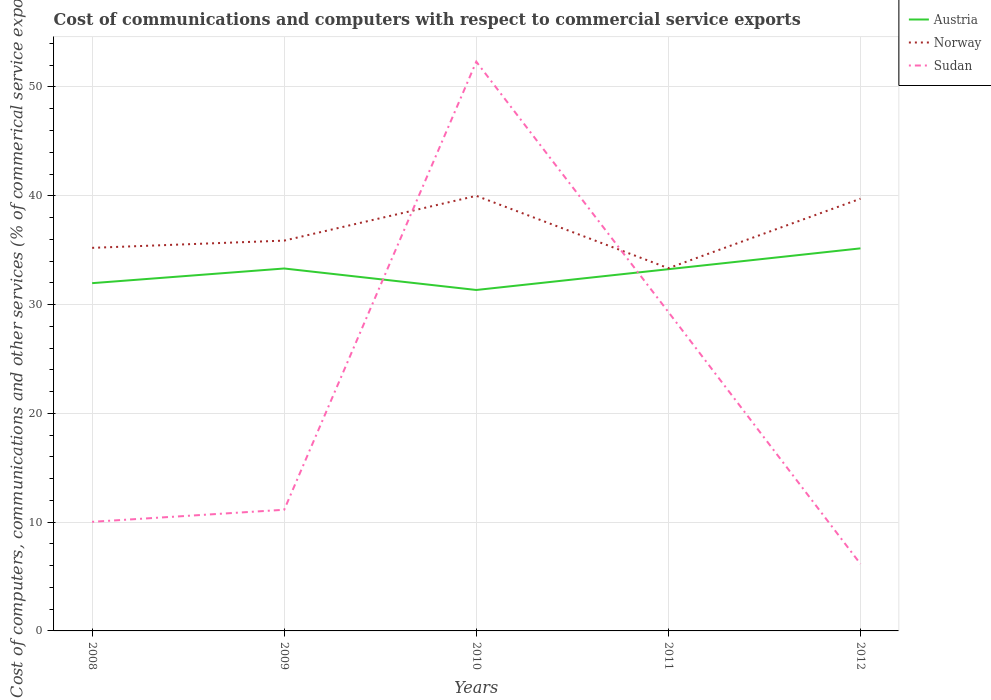Does the line corresponding to Norway intersect with the line corresponding to Sudan?
Offer a terse response. Yes. Is the number of lines equal to the number of legend labels?
Provide a short and direct response. Yes. Across all years, what is the maximum cost of communications and computers in Norway?
Provide a succinct answer. 33.34. What is the total cost of communications and computers in Sudan in the graph?
Keep it short and to the point. -19.29. What is the difference between the highest and the second highest cost of communications and computers in Austria?
Keep it short and to the point. 3.83. What is the difference between the highest and the lowest cost of communications and computers in Norway?
Provide a short and direct response. 2. Does the graph contain grids?
Your answer should be very brief. Yes. How many legend labels are there?
Your answer should be compact. 3. How are the legend labels stacked?
Give a very brief answer. Vertical. What is the title of the graph?
Offer a terse response. Cost of communications and computers with respect to commercial service exports. What is the label or title of the Y-axis?
Your response must be concise. Cost of computers, communications and other services (% of commerical service exports). What is the Cost of computers, communications and other services (% of commerical service exports) in Austria in 2008?
Provide a succinct answer. 31.97. What is the Cost of computers, communications and other services (% of commerical service exports) in Norway in 2008?
Ensure brevity in your answer.  35.21. What is the Cost of computers, communications and other services (% of commerical service exports) of Sudan in 2008?
Provide a short and direct response. 10.03. What is the Cost of computers, communications and other services (% of commerical service exports) in Austria in 2009?
Offer a terse response. 33.31. What is the Cost of computers, communications and other services (% of commerical service exports) of Norway in 2009?
Provide a short and direct response. 35.88. What is the Cost of computers, communications and other services (% of commerical service exports) in Sudan in 2009?
Your answer should be compact. 11.14. What is the Cost of computers, communications and other services (% of commerical service exports) in Austria in 2010?
Provide a short and direct response. 31.34. What is the Cost of computers, communications and other services (% of commerical service exports) in Norway in 2010?
Keep it short and to the point. 39.99. What is the Cost of computers, communications and other services (% of commerical service exports) of Sudan in 2010?
Keep it short and to the point. 52.32. What is the Cost of computers, communications and other services (% of commerical service exports) in Austria in 2011?
Your answer should be very brief. 33.25. What is the Cost of computers, communications and other services (% of commerical service exports) of Norway in 2011?
Your response must be concise. 33.34. What is the Cost of computers, communications and other services (% of commerical service exports) in Sudan in 2011?
Your response must be concise. 29.31. What is the Cost of computers, communications and other services (% of commerical service exports) of Austria in 2012?
Keep it short and to the point. 35.16. What is the Cost of computers, communications and other services (% of commerical service exports) of Norway in 2012?
Offer a very short reply. 39.73. What is the Cost of computers, communications and other services (% of commerical service exports) of Sudan in 2012?
Offer a very short reply. 6.16. Across all years, what is the maximum Cost of computers, communications and other services (% of commerical service exports) of Austria?
Your answer should be very brief. 35.16. Across all years, what is the maximum Cost of computers, communications and other services (% of commerical service exports) in Norway?
Offer a terse response. 39.99. Across all years, what is the maximum Cost of computers, communications and other services (% of commerical service exports) in Sudan?
Provide a short and direct response. 52.32. Across all years, what is the minimum Cost of computers, communications and other services (% of commerical service exports) of Austria?
Your response must be concise. 31.34. Across all years, what is the minimum Cost of computers, communications and other services (% of commerical service exports) in Norway?
Make the answer very short. 33.34. Across all years, what is the minimum Cost of computers, communications and other services (% of commerical service exports) in Sudan?
Provide a short and direct response. 6.16. What is the total Cost of computers, communications and other services (% of commerical service exports) of Austria in the graph?
Offer a terse response. 165.03. What is the total Cost of computers, communications and other services (% of commerical service exports) in Norway in the graph?
Your response must be concise. 184.15. What is the total Cost of computers, communications and other services (% of commerical service exports) in Sudan in the graph?
Keep it short and to the point. 108.96. What is the difference between the Cost of computers, communications and other services (% of commerical service exports) of Austria in 2008 and that in 2009?
Offer a terse response. -1.35. What is the difference between the Cost of computers, communications and other services (% of commerical service exports) in Norway in 2008 and that in 2009?
Provide a succinct answer. -0.67. What is the difference between the Cost of computers, communications and other services (% of commerical service exports) in Sudan in 2008 and that in 2009?
Offer a terse response. -1.11. What is the difference between the Cost of computers, communications and other services (% of commerical service exports) in Austria in 2008 and that in 2010?
Your answer should be compact. 0.63. What is the difference between the Cost of computers, communications and other services (% of commerical service exports) of Norway in 2008 and that in 2010?
Provide a short and direct response. -4.78. What is the difference between the Cost of computers, communications and other services (% of commerical service exports) of Sudan in 2008 and that in 2010?
Provide a short and direct response. -42.3. What is the difference between the Cost of computers, communications and other services (% of commerical service exports) of Austria in 2008 and that in 2011?
Your answer should be compact. -1.28. What is the difference between the Cost of computers, communications and other services (% of commerical service exports) of Norway in 2008 and that in 2011?
Your response must be concise. 1.87. What is the difference between the Cost of computers, communications and other services (% of commerical service exports) in Sudan in 2008 and that in 2011?
Give a very brief answer. -19.29. What is the difference between the Cost of computers, communications and other services (% of commerical service exports) of Austria in 2008 and that in 2012?
Your answer should be compact. -3.2. What is the difference between the Cost of computers, communications and other services (% of commerical service exports) in Norway in 2008 and that in 2012?
Your answer should be very brief. -4.52. What is the difference between the Cost of computers, communications and other services (% of commerical service exports) in Sudan in 2008 and that in 2012?
Your response must be concise. 3.87. What is the difference between the Cost of computers, communications and other services (% of commerical service exports) in Austria in 2009 and that in 2010?
Give a very brief answer. 1.98. What is the difference between the Cost of computers, communications and other services (% of commerical service exports) in Norway in 2009 and that in 2010?
Give a very brief answer. -4.12. What is the difference between the Cost of computers, communications and other services (% of commerical service exports) in Sudan in 2009 and that in 2010?
Your response must be concise. -41.19. What is the difference between the Cost of computers, communications and other services (% of commerical service exports) in Austria in 2009 and that in 2011?
Ensure brevity in your answer.  0.06. What is the difference between the Cost of computers, communications and other services (% of commerical service exports) of Norway in 2009 and that in 2011?
Make the answer very short. 2.54. What is the difference between the Cost of computers, communications and other services (% of commerical service exports) in Sudan in 2009 and that in 2011?
Provide a succinct answer. -18.18. What is the difference between the Cost of computers, communications and other services (% of commerical service exports) of Austria in 2009 and that in 2012?
Keep it short and to the point. -1.85. What is the difference between the Cost of computers, communications and other services (% of commerical service exports) in Norway in 2009 and that in 2012?
Ensure brevity in your answer.  -3.85. What is the difference between the Cost of computers, communications and other services (% of commerical service exports) of Sudan in 2009 and that in 2012?
Your response must be concise. 4.98. What is the difference between the Cost of computers, communications and other services (% of commerical service exports) in Austria in 2010 and that in 2011?
Keep it short and to the point. -1.91. What is the difference between the Cost of computers, communications and other services (% of commerical service exports) of Norway in 2010 and that in 2011?
Your response must be concise. 6.65. What is the difference between the Cost of computers, communications and other services (% of commerical service exports) of Sudan in 2010 and that in 2011?
Give a very brief answer. 23.01. What is the difference between the Cost of computers, communications and other services (% of commerical service exports) of Austria in 2010 and that in 2012?
Give a very brief answer. -3.83. What is the difference between the Cost of computers, communications and other services (% of commerical service exports) in Norway in 2010 and that in 2012?
Your answer should be very brief. 0.27. What is the difference between the Cost of computers, communications and other services (% of commerical service exports) of Sudan in 2010 and that in 2012?
Ensure brevity in your answer.  46.16. What is the difference between the Cost of computers, communications and other services (% of commerical service exports) in Austria in 2011 and that in 2012?
Keep it short and to the point. -1.91. What is the difference between the Cost of computers, communications and other services (% of commerical service exports) of Norway in 2011 and that in 2012?
Offer a terse response. -6.39. What is the difference between the Cost of computers, communications and other services (% of commerical service exports) in Sudan in 2011 and that in 2012?
Provide a short and direct response. 23.15. What is the difference between the Cost of computers, communications and other services (% of commerical service exports) in Austria in 2008 and the Cost of computers, communications and other services (% of commerical service exports) in Norway in 2009?
Provide a short and direct response. -3.91. What is the difference between the Cost of computers, communications and other services (% of commerical service exports) of Austria in 2008 and the Cost of computers, communications and other services (% of commerical service exports) of Sudan in 2009?
Give a very brief answer. 20.83. What is the difference between the Cost of computers, communications and other services (% of commerical service exports) of Norway in 2008 and the Cost of computers, communications and other services (% of commerical service exports) of Sudan in 2009?
Provide a succinct answer. 24.07. What is the difference between the Cost of computers, communications and other services (% of commerical service exports) in Austria in 2008 and the Cost of computers, communications and other services (% of commerical service exports) in Norway in 2010?
Keep it short and to the point. -8.03. What is the difference between the Cost of computers, communications and other services (% of commerical service exports) of Austria in 2008 and the Cost of computers, communications and other services (% of commerical service exports) of Sudan in 2010?
Your answer should be very brief. -20.36. What is the difference between the Cost of computers, communications and other services (% of commerical service exports) of Norway in 2008 and the Cost of computers, communications and other services (% of commerical service exports) of Sudan in 2010?
Offer a very short reply. -17.11. What is the difference between the Cost of computers, communications and other services (% of commerical service exports) in Austria in 2008 and the Cost of computers, communications and other services (% of commerical service exports) in Norway in 2011?
Your answer should be very brief. -1.38. What is the difference between the Cost of computers, communications and other services (% of commerical service exports) in Austria in 2008 and the Cost of computers, communications and other services (% of commerical service exports) in Sudan in 2011?
Your response must be concise. 2.65. What is the difference between the Cost of computers, communications and other services (% of commerical service exports) of Norway in 2008 and the Cost of computers, communications and other services (% of commerical service exports) of Sudan in 2011?
Your answer should be compact. 5.9. What is the difference between the Cost of computers, communications and other services (% of commerical service exports) in Austria in 2008 and the Cost of computers, communications and other services (% of commerical service exports) in Norway in 2012?
Provide a succinct answer. -7.76. What is the difference between the Cost of computers, communications and other services (% of commerical service exports) in Austria in 2008 and the Cost of computers, communications and other services (% of commerical service exports) in Sudan in 2012?
Your answer should be compact. 25.81. What is the difference between the Cost of computers, communications and other services (% of commerical service exports) in Norway in 2008 and the Cost of computers, communications and other services (% of commerical service exports) in Sudan in 2012?
Your answer should be very brief. 29.05. What is the difference between the Cost of computers, communications and other services (% of commerical service exports) of Austria in 2009 and the Cost of computers, communications and other services (% of commerical service exports) of Norway in 2010?
Provide a succinct answer. -6.68. What is the difference between the Cost of computers, communications and other services (% of commerical service exports) in Austria in 2009 and the Cost of computers, communications and other services (% of commerical service exports) in Sudan in 2010?
Provide a short and direct response. -19.01. What is the difference between the Cost of computers, communications and other services (% of commerical service exports) in Norway in 2009 and the Cost of computers, communications and other services (% of commerical service exports) in Sudan in 2010?
Make the answer very short. -16.45. What is the difference between the Cost of computers, communications and other services (% of commerical service exports) in Austria in 2009 and the Cost of computers, communications and other services (% of commerical service exports) in Norway in 2011?
Provide a succinct answer. -0.03. What is the difference between the Cost of computers, communications and other services (% of commerical service exports) of Austria in 2009 and the Cost of computers, communications and other services (% of commerical service exports) of Sudan in 2011?
Your answer should be compact. 4. What is the difference between the Cost of computers, communications and other services (% of commerical service exports) in Norway in 2009 and the Cost of computers, communications and other services (% of commerical service exports) in Sudan in 2011?
Keep it short and to the point. 6.56. What is the difference between the Cost of computers, communications and other services (% of commerical service exports) in Austria in 2009 and the Cost of computers, communications and other services (% of commerical service exports) in Norway in 2012?
Provide a succinct answer. -6.41. What is the difference between the Cost of computers, communications and other services (% of commerical service exports) of Austria in 2009 and the Cost of computers, communications and other services (% of commerical service exports) of Sudan in 2012?
Provide a short and direct response. 27.16. What is the difference between the Cost of computers, communications and other services (% of commerical service exports) of Norway in 2009 and the Cost of computers, communications and other services (% of commerical service exports) of Sudan in 2012?
Your response must be concise. 29.72. What is the difference between the Cost of computers, communications and other services (% of commerical service exports) in Austria in 2010 and the Cost of computers, communications and other services (% of commerical service exports) in Norway in 2011?
Ensure brevity in your answer.  -2. What is the difference between the Cost of computers, communications and other services (% of commerical service exports) in Austria in 2010 and the Cost of computers, communications and other services (% of commerical service exports) in Sudan in 2011?
Provide a short and direct response. 2.03. What is the difference between the Cost of computers, communications and other services (% of commerical service exports) in Norway in 2010 and the Cost of computers, communications and other services (% of commerical service exports) in Sudan in 2011?
Provide a short and direct response. 10.68. What is the difference between the Cost of computers, communications and other services (% of commerical service exports) in Austria in 2010 and the Cost of computers, communications and other services (% of commerical service exports) in Norway in 2012?
Offer a terse response. -8.39. What is the difference between the Cost of computers, communications and other services (% of commerical service exports) of Austria in 2010 and the Cost of computers, communications and other services (% of commerical service exports) of Sudan in 2012?
Give a very brief answer. 25.18. What is the difference between the Cost of computers, communications and other services (% of commerical service exports) in Norway in 2010 and the Cost of computers, communications and other services (% of commerical service exports) in Sudan in 2012?
Your response must be concise. 33.83. What is the difference between the Cost of computers, communications and other services (% of commerical service exports) in Austria in 2011 and the Cost of computers, communications and other services (% of commerical service exports) in Norway in 2012?
Make the answer very short. -6.48. What is the difference between the Cost of computers, communications and other services (% of commerical service exports) of Austria in 2011 and the Cost of computers, communications and other services (% of commerical service exports) of Sudan in 2012?
Offer a terse response. 27.09. What is the difference between the Cost of computers, communications and other services (% of commerical service exports) of Norway in 2011 and the Cost of computers, communications and other services (% of commerical service exports) of Sudan in 2012?
Provide a succinct answer. 27.18. What is the average Cost of computers, communications and other services (% of commerical service exports) in Austria per year?
Provide a succinct answer. 33.01. What is the average Cost of computers, communications and other services (% of commerical service exports) in Norway per year?
Provide a short and direct response. 36.83. What is the average Cost of computers, communications and other services (% of commerical service exports) in Sudan per year?
Your answer should be compact. 21.79. In the year 2008, what is the difference between the Cost of computers, communications and other services (% of commerical service exports) of Austria and Cost of computers, communications and other services (% of commerical service exports) of Norway?
Offer a very short reply. -3.25. In the year 2008, what is the difference between the Cost of computers, communications and other services (% of commerical service exports) in Austria and Cost of computers, communications and other services (% of commerical service exports) in Sudan?
Provide a short and direct response. 21.94. In the year 2008, what is the difference between the Cost of computers, communications and other services (% of commerical service exports) in Norway and Cost of computers, communications and other services (% of commerical service exports) in Sudan?
Keep it short and to the point. 25.19. In the year 2009, what is the difference between the Cost of computers, communications and other services (% of commerical service exports) in Austria and Cost of computers, communications and other services (% of commerical service exports) in Norway?
Your response must be concise. -2.56. In the year 2009, what is the difference between the Cost of computers, communications and other services (% of commerical service exports) of Austria and Cost of computers, communications and other services (% of commerical service exports) of Sudan?
Provide a succinct answer. 22.18. In the year 2009, what is the difference between the Cost of computers, communications and other services (% of commerical service exports) in Norway and Cost of computers, communications and other services (% of commerical service exports) in Sudan?
Your response must be concise. 24.74. In the year 2010, what is the difference between the Cost of computers, communications and other services (% of commerical service exports) of Austria and Cost of computers, communications and other services (% of commerical service exports) of Norway?
Give a very brief answer. -8.65. In the year 2010, what is the difference between the Cost of computers, communications and other services (% of commerical service exports) in Austria and Cost of computers, communications and other services (% of commerical service exports) in Sudan?
Provide a short and direct response. -20.98. In the year 2010, what is the difference between the Cost of computers, communications and other services (% of commerical service exports) of Norway and Cost of computers, communications and other services (% of commerical service exports) of Sudan?
Provide a succinct answer. -12.33. In the year 2011, what is the difference between the Cost of computers, communications and other services (% of commerical service exports) of Austria and Cost of computers, communications and other services (% of commerical service exports) of Norway?
Make the answer very short. -0.09. In the year 2011, what is the difference between the Cost of computers, communications and other services (% of commerical service exports) of Austria and Cost of computers, communications and other services (% of commerical service exports) of Sudan?
Offer a terse response. 3.94. In the year 2011, what is the difference between the Cost of computers, communications and other services (% of commerical service exports) in Norway and Cost of computers, communications and other services (% of commerical service exports) in Sudan?
Provide a succinct answer. 4.03. In the year 2012, what is the difference between the Cost of computers, communications and other services (% of commerical service exports) in Austria and Cost of computers, communications and other services (% of commerical service exports) in Norway?
Provide a short and direct response. -4.56. In the year 2012, what is the difference between the Cost of computers, communications and other services (% of commerical service exports) in Austria and Cost of computers, communications and other services (% of commerical service exports) in Sudan?
Make the answer very short. 29. In the year 2012, what is the difference between the Cost of computers, communications and other services (% of commerical service exports) of Norway and Cost of computers, communications and other services (% of commerical service exports) of Sudan?
Keep it short and to the point. 33.57. What is the ratio of the Cost of computers, communications and other services (% of commerical service exports) in Austria in 2008 to that in 2009?
Provide a succinct answer. 0.96. What is the ratio of the Cost of computers, communications and other services (% of commerical service exports) in Norway in 2008 to that in 2009?
Ensure brevity in your answer.  0.98. What is the ratio of the Cost of computers, communications and other services (% of commerical service exports) in Sudan in 2008 to that in 2009?
Keep it short and to the point. 0.9. What is the ratio of the Cost of computers, communications and other services (% of commerical service exports) in Norway in 2008 to that in 2010?
Ensure brevity in your answer.  0.88. What is the ratio of the Cost of computers, communications and other services (% of commerical service exports) in Sudan in 2008 to that in 2010?
Your answer should be compact. 0.19. What is the ratio of the Cost of computers, communications and other services (% of commerical service exports) of Austria in 2008 to that in 2011?
Make the answer very short. 0.96. What is the ratio of the Cost of computers, communications and other services (% of commerical service exports) of Norway in 2008 to that in 2011?
Your answer should be compact. 1.06. What is the ratio of the Cost of computers, communications and other services (% of commerical service exports) in Sudan in 2008 to that in 2011?
Ensure brevity in your answer.  0.34. What is the ratio of the Cost of computers, communications and other services (% of commerical service exports) in Austria in 2008 to that in 2012?
Your answer should be very brief. 0.91. What is the ratio of the Cost of computers, communications and other services (% of commerical service exports) of Norway in 2008 to that in 2012?
Offer a very short reply. 0.89. What is the ratio of the Cost of computers, communications and other services (% of commerical service exports) in Sudan in 2008 to that in 2012?
Offer a very short reply. 1.63. What is the ratio of the Cost of computers, communications and other services (% of commerical service exports) in Austria in 2009 to that in 2010?
Provide a succinct answer. 1.06. What is the ratio of the Cost of computers, communications and other services (% of commerical service exports) of Norway in 2009 to that in 2010?
Make the answer very short. 0.9. What is the ratio of the Cost of computers, communications and other services (% of commerical service exports) in Sudan in 2009 to that in 2010?
Ensure brevity in your answer.  0.21. What is the ratio of the Cost of computers, communications and other services (% of commerical service exports) of Austria in 2009 to that in 2011?
Provide a succinct answer. 1. What is the ratio of the Cost of computers, communications and other services (% of commerical service exports) of Norway in 2009 to that in 2011?
Your answer should be compact. 1.08. What is the ratio of the Cost of computers, communications and other services (% of commerical service exports) of Sudan in 2009 to that in 2011?
Provide a succinct answer. 0.38. What is the ratio of the Cost of computers, communications and other services (% of commerical service exports) in Norway in 2009 to that in 2012?
Make the answer very short. 0.9. What is the ratio of the Cost of computers, communications and other services (% of commerical service exports) of Sudan in 2009 to that in 2012?
Your answer should be very brief. 1.81. What is the ratio of the Cost of computers, communications and other services (% of commerical service exports) in Austria in 2010 to that in 2011?
Make the answer very short. 0.94. What is the ratio of the Cost of computers, communications and other services (% of commerical service exports) in Norway in 2010 to that in 2011?
Offer a very short reply. 1.2. What is the ratio of the Cost of computers, communications and other services (% of commerical service exports) of Sudan in 2010 to that in 2011?
Offer a very short reply. 1.78. What is the ratio of the Cost of computers, communications and other services (% of commerical service exports) of Austria in 2010 to that in 2012?
Give a very brief answer. 0.89. What is the ratio of the Cost of computers, communications and other services (% of commerical service exports) of Sudan in 2010 to that in 2012?
Provide a succinct answer. 8.5. What is the ratio of the Cost of computers, communications and other services (% of commerical service exports) of Austria in 2011 to that in 2012?
Keep it short and to the point. 0.95. What is the ratio of the Cost of computers, communications and other services (% of commerical service exports) of Norway in 2011 to that in 2012?
Your answer should be very brief. 0.84. What is the ratio of the Cost of computers, communications and other services (% of commerical service exports) in Sudan in 2011 to that in 2012?
Keep it short and to the point. 4.76. What is the difference between the highest and the second highest Cost of computers, communications and other services (% of commerical service exports) in Austria?
Ensure brevity in your answer.  1.85. What is the difference between the highest and the second highest Cost of computers, communications and other services (% of commerical service exports) in Norway?
Make the answer very short. 0.27. What is the difference between the highest and the second highest Cost of computers, communications and other services (% of commerical service exports) in Sudan?
Provide a short and direct response. 23.01. What is the difference between the highest and the lowest Cost of computers, communications and other services (% of commerical service exports) in Austria?
Offer a terse response. 3.83. What is the difference between the highest and the lowest Cost of computers, communications and other services (% of commerical service exports) of Norway?
Provide a short and direct response. 6.65. What is the difference between the highest and the lowest Cost of computers, communications and other services (% of commerical service exports) of Sudan?
Make the answer very short. 46.16. 